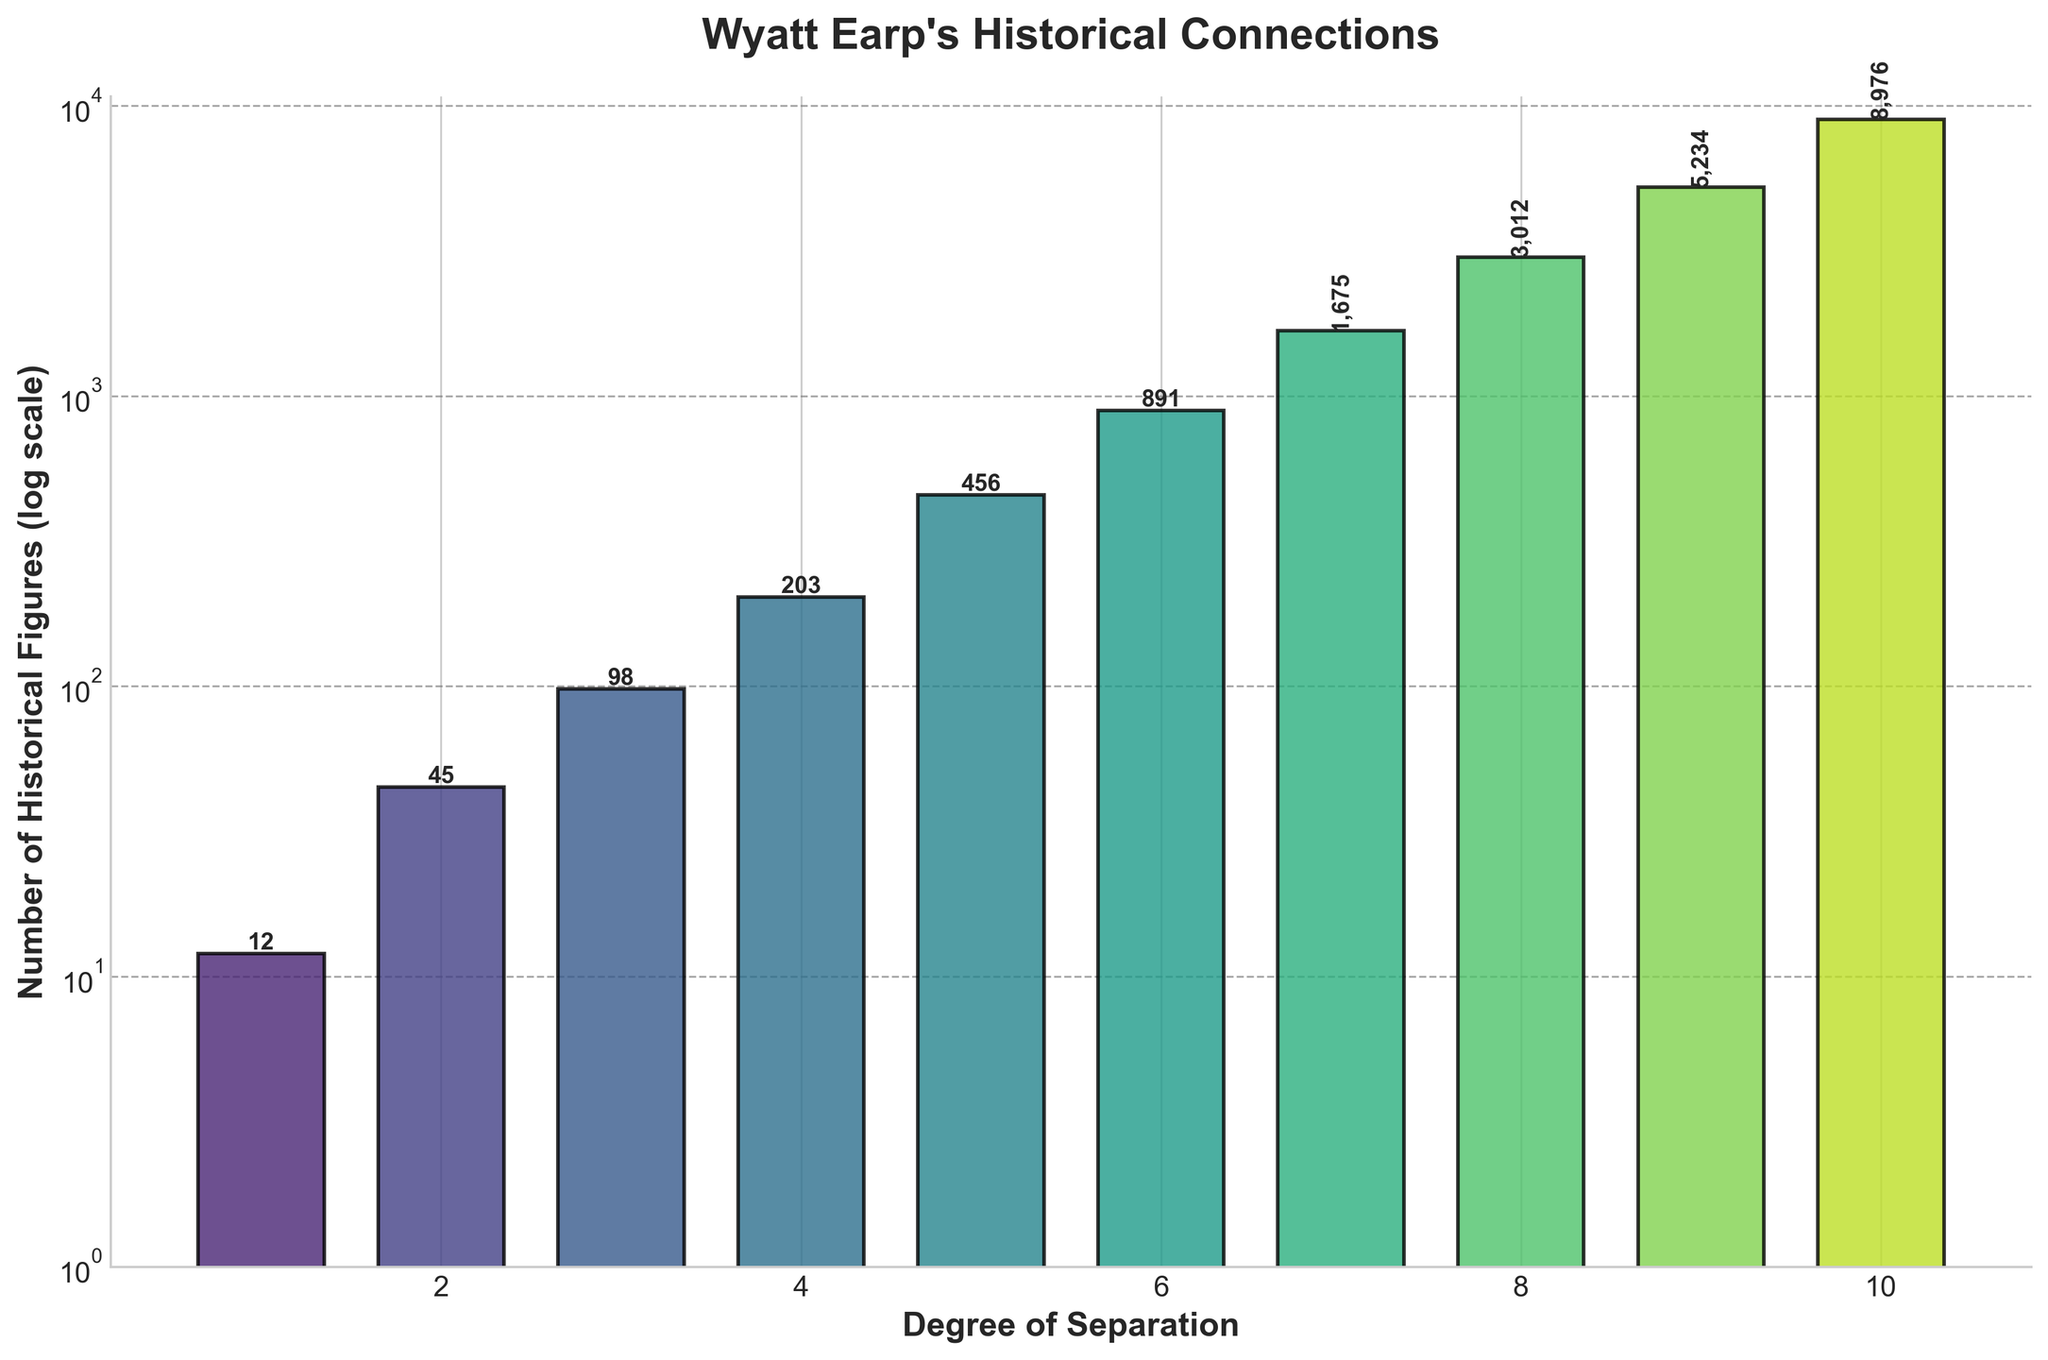What is the number of historical figures connected to Wyatt Earp at 3 degrees of separation? Look at the bar corresponding to 3 degrees of separation. The height of the bar represents the number of connected historical figures, which is 98.
Answer: 98 What is the degree of separation with the highest number of historical figures connected to Wyatt Earp? Look for the tallest bar in the chart. It corresponds to the 10th degree of separation with 8976 historical figures.
Answer: 10 What is the sum of historical figures connected to Wyatt Earp at 1 and 2 degrees of separation? Sum the number of historical figures connected at 1 degree (12) and 2 degrees (45). \(12 + 45 = 57\)
Answer: 57 Which degree of separation has fewer historical figures connected to Wyatt Earp, 7 or 8? Compare the height of the bars at 7 degrees (1675 historical figures) and 8 degrees (3012 historical figures). 1675 is less than 3012.
Answer: 7 What is the average number of historical figures connected to Wyatt Earp across all 10 degrees of separation? Sum the number of historical figures for all degrees: \(12 + 45 + 98 + 203 + 456 + 891 + 1675 + 3012 + 5234 + 8976 = 18502\). Divide by 10 (number of degrees): \(18502 / 10 = 1850.2\).
Answer: 1850.2 How many more historical figures are connected to Wyatt Earp at 5 degrees of separation compared to 4 degrees of separation? Subtract the number of historical figures at 4 degrees (203) from the number at 5 degrees (456). \(456 - 203 = 253\)
Answer: 253 Is the number of historical figures at 6 degrees of separation closer to the number at 5 degrees or to the number at 7 degrees? The number at 6 degrees is 891. The difference with the number at 5 degrees (456) is \(891 - 456 = 435\), and the difference with the number at 7 degrees (1675) is \(1675 - 891 = 784\). Since 435 is less than 784, it's closer to 5 degrees.
Answer: 5 degrees What is the approximate visual difference in height between the bars for 1 degree and 10 degrees of separation? Compare the heights visually; the bar for 10 degrees is much higher than that for 1 degree. Specifically, 10 degrees has 8976 figures, and 1 degree has only 12, which gives a difference in height representing 8964 figures.
Answer: 8964 How many degrees of separation have more than 1000 historical figures connected to Wyatt Earp? Check each degree: degrees 7, 8, 9, and 10 have more than 1000 figures. So, there are 4 such degrees.
Answer: 4 What is the difference in the number of historical figures between the highest and the lowest degree of separation shown? The highest number is at 10 degrees (8976), and the lowest is at 1 degree (12). The difference is \(8976 - 12 = 8964\).
Answer: 8964 